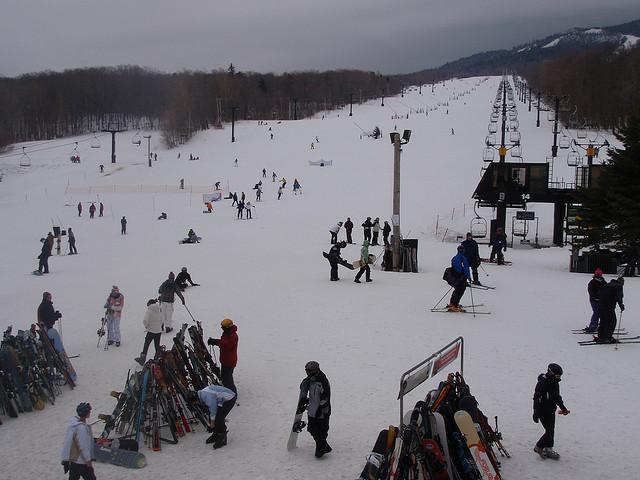Is it light outside?
Keep it brief. Yes. Is the sun shining?
Quick response, please. No. Are people on the ski lift?
Answer briefly. No. How many skiers are there?
Concise answer only. Many. How many people are in the background?
Be succinct. 25. Is it cold?
Quick response, please. Yes. Is it raining?
Concise answer only. No. How many people are watching?
Write a very short answer. 10. Why should people walk carefully in this image?
Give a very brief answer. Slippery. How many people are in the picture?
Be succinct. 50. What sport is it?
Write a very short answer. Skiing. How is the sky?
Short answer required. Overcast. What is the pastime taking place?
Keep it brief. Skiing. 